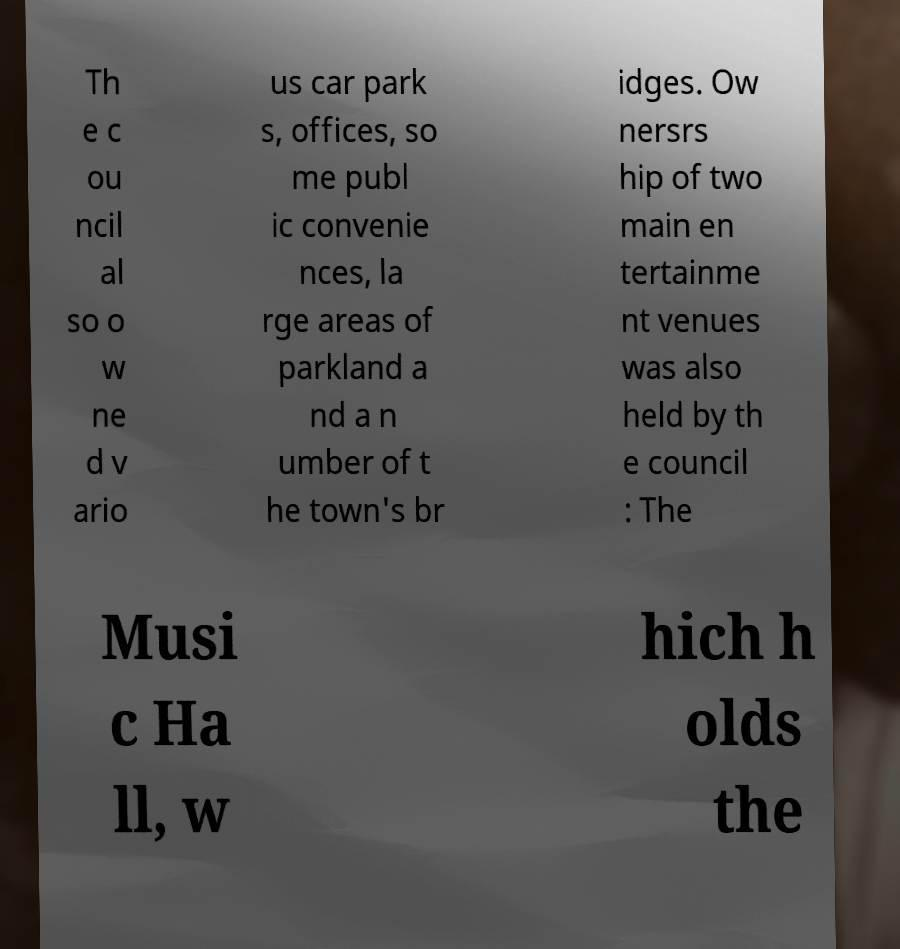Can you accurately transcribe the text from the provided image for me? Th e c ou ncil al so o w ne d v ario us car park s, offices, so me publ ic convenie nces, la rge areas of parkland a nd a n umber of t he town's br idges. Ow nersrs hip of two main en tertainme nt venues was also held by th e council : The Musi c Ha ll, w hich h olds the 